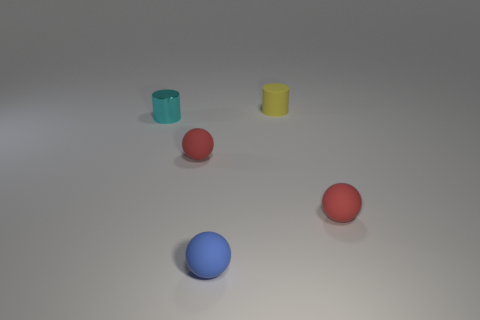Is there any other thing that has the same material as the cyan object?
Keep it short and to the point. No. The other rubber object that is the same shape as the cyan thing is what size?
Make the answer very short. Small. The small rubber object that is behind the small cyan cylinder has what shape?
Give a very brief answer. Cylinder. Is the material of the tiny cylinder behind the tiny cyan object the same as the tiny cylinder that is on the left side of the tiny yellow rubber object?
Offer a terse response. No. What is the shape of the tiny cyan shiny object?
Give a very brief answer. Cylinder. Are there the same number of matte spheres behind the small blue rubber sphere and cylinders?
Give a very brief answer. Yes. Are there any tiny red balls made of the same material as the tiny blue sphere?
Provide a short and direct response. Yes. Does the tiny matte object that is on the left side of the small blue ball have the same shape as the tiny red object right of the blue rubber ball?
Ensure brevity in your answer.  Yes. Are there any small yellow metal balls?
Ensure brevity in your answer.  No. What color is the matte cylinder that is the same size as the cyan thing?
Your answer should be very brief. Yellow. 